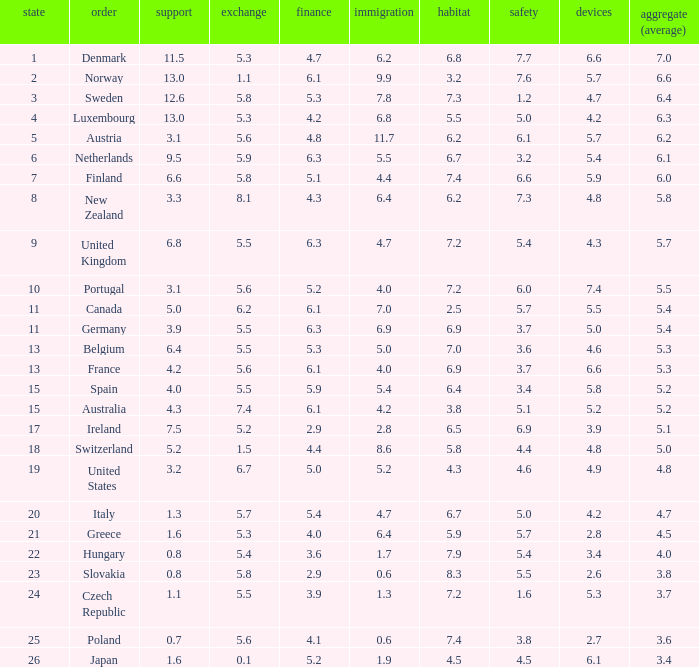What is the migration rating when trade is 5.7? 4.7. I'm looking to parse the entire table for insights. Could you assist me with that? {'header': ['state', 'order', 'support', 'exchange', 'finance', 'immigration', 'habitat', 'safety', 'devices', 'aggregate (average)'], 'rows': [['1', 'Denmark', '11.5', '5.3', '4.7', '6.2', '6.8', '7.7', '6.6', '7.0'], ['2', 'Norway', '13.0', '1.1', '6.1', '9.9', '3.2', '7.6', '5.7', '6.6'], ['3', 'Sweden', '12.6', '5.8', '5.3', '7.8', '7.3', '1.2', '4.7', '6.4'], ['4', 'Luxembourg', '13.0', '5.3', '4.2', '6.8', '5.5', '5.0', '4.2', '6.3'], ['5', 'Austria', '3.1', '5.6', '4.8', '11.7', '6.2', '6.1', '5.7', '6.2'], ['6', 'Netherlands', '9.5', '5.9', '6.3', '5.5', '6.7', '3.2', '5.4', '6.1'], ['7', 'Finland', '6.6', '5.8', '5.1', '4.4', '7.4', '6.6', '5.9', '6.0'], ['8', 'New Zealand', '3.3', '8.1', '4.3', '6.4', '6.2', '7.3', '4.8', '5.8'], ['9', 'United Kingdom', '6.8', '5.5', '6.3', '4.7', '7.2', '5.4', '4.3', '5.7'], ['10', 'Portugal', '3.1', '5.6', '5.2', '4.0', '7.2', '6.0', '7.4', '5.5'], ['11', 'Canada', '5.0', '6.2', '6.1', '7.0', '2.5', '5.7', '5.5', '5.4'], ['11', 'Germany', '3.9', '5.5', '6.3', '6.9', '6.9', '3.7', '5.0', '5.4'], ['13', 'Belgium', '6.4', '5.5', '5.3', '5.0', '7.0', '3.6', '4.6', '5.3'], ['13', 'France', '4.2', '5.6', '6.1', '4.0', '6.9', '3.7', '6.6', '5.3'], ['15', 'Spain', '4.0', '5.5', '5.9', '5.4', '6.4', '3.4', '5.8', '5.2'], ['15', 'Australia', '4.3', '7.4', '6.1', '4.2', '3.8', '5.1', '5.2', '5.2'], ['17', 'Ireland', '7.5', '5.2', '2.9', '2.8', '6.5', '6.9', '3.9', '5.1'], ['18', 'Switzerland', '5.2', '1.5', '4.4', '8.6', '5.8', '4.4', '4.8', '5.0'], ['19', 'United States', '3.2', '6.7', '5.0', '5.2', '4.3', '4.6', '4.9', '4.8'], ['20', 'Italy', '1.3', '5.7', '5.4', '4.7', '6.7', '5.0', '4.2', '4.7'], ['21', 'Greece', '1.6', '5.3', '4.0', '6.4', '5.9', '5.7', '2.8', '4.5'], ['22', 'Hungary', '0.8', '5.4', '3.6', '1.7', '7.9', '5.4', '3.4', '4.0'], ['23', 'Slovakia', '0.8', '5.8', '2.9', '0.6', '8.3', '5.5', '2.6', '3.8'], ['24', 'Czech Republic', '1.1', '5.5', '3.9', '1.3', '7.2', '1.6', '5.3', '3.7'], ['25', 'Poland', '0.7', '5.6', '4.1', '0.6', '7.4', '3.8', '2.7', '3.6'], ['26', 'Japan', '1.6', '0.1', '5.2', '1.9', '4.5', '4.5', '6.1', '3.4']]} 